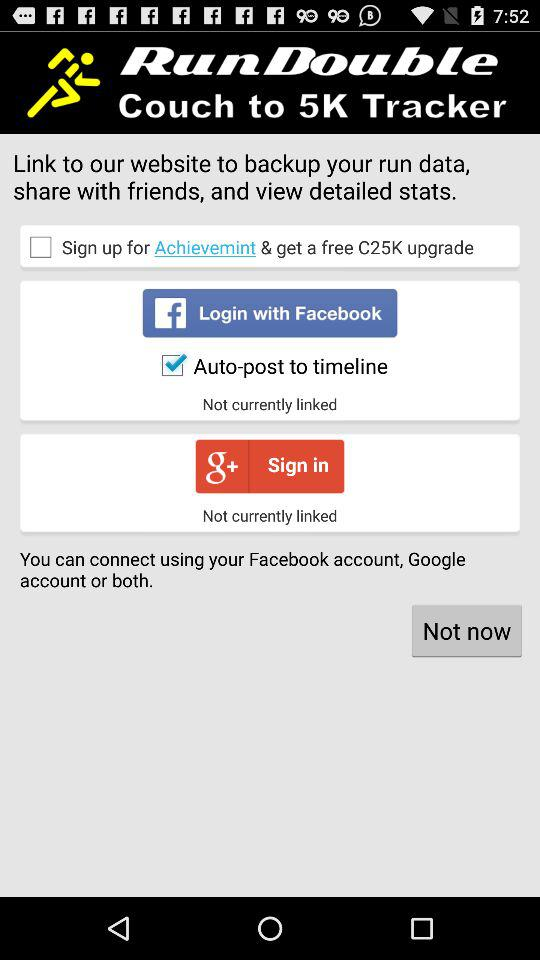What is the application name? The application name is "RunDouble Couch to 5K Tracker". 